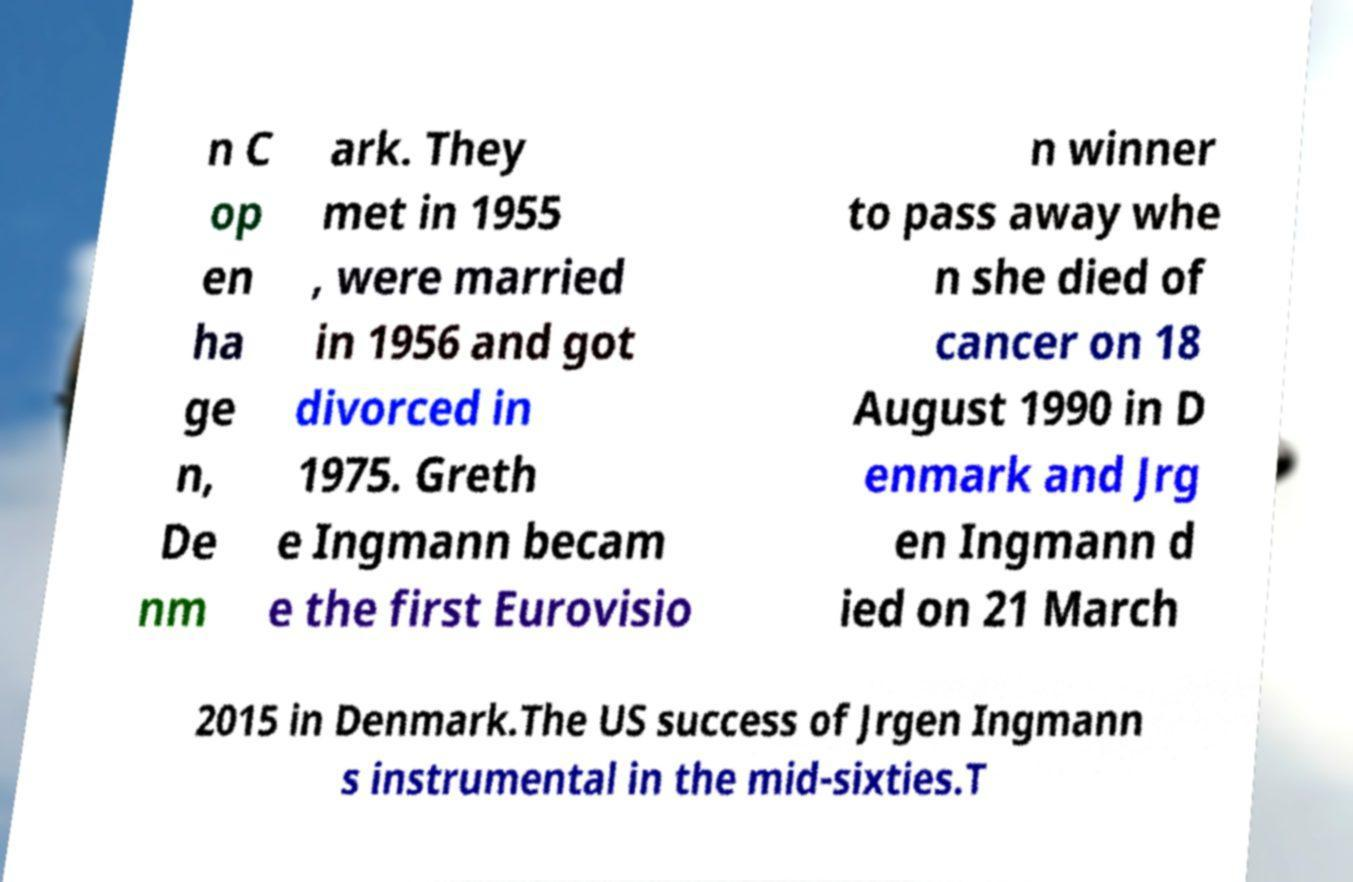Could you extract and type out the text from this image? n C op en ha ge n, De nm ark. They met in 1955 , were married in 1956 and got divorced in 1975. Greth e Ingmann becam e the first Eurovisio n winner to pass away whe n she died of cancer on 18 August 1990 in D enmark and Jrg en Ingmann d ied on 21 March 2015 in Denmark.The US success of Jrgen Ingmann s instrumental in the mid-sixties.T 